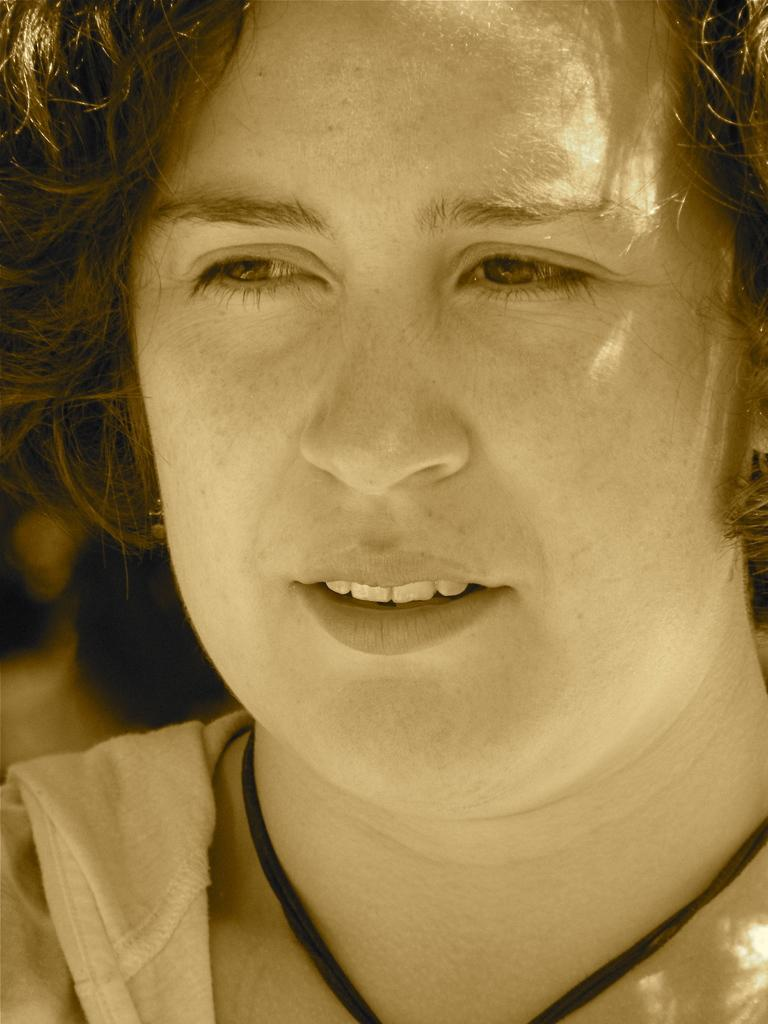What is the main subject of the image? There is a person's face in the image. How deep is the lake in the image? There is no lake present in the image; it features a person's face. What is the price of the ray in the image? There is no ray present in the image, and therefore no price can be determined. 